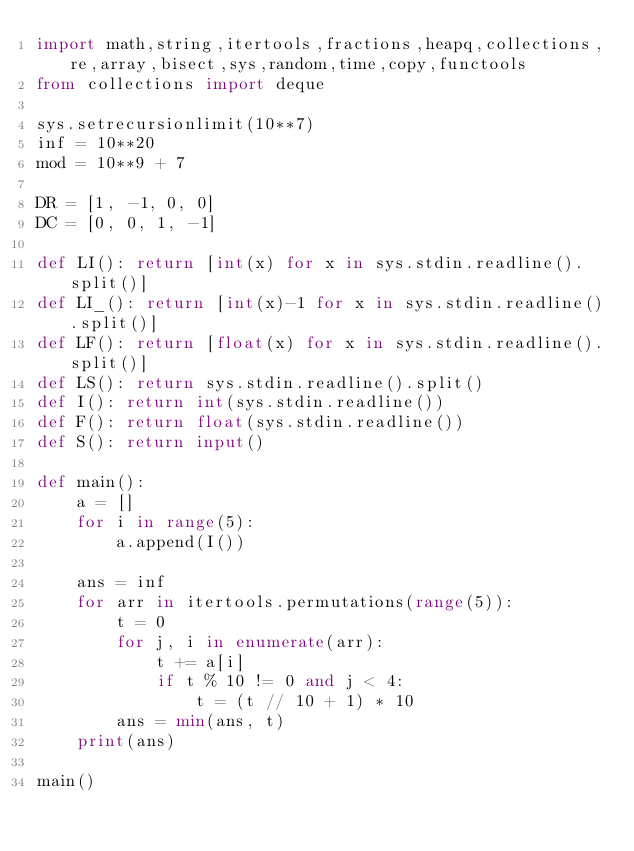<code> <loc_0><loc_0><loc_500><loc_500><_Python_>import math,string,itertools,fractions,heapq,collections,re,array,bisect,sys,random,time,copy,functools
from collections import deque

sys.setrecursionlimit(10**7)
inf = 10**20
mod = 10**9 + 7

DR = [1, -1, 0, 0]
DC = [0, 0, 1, -1]

def LI(): return [int(x) for x in sys.stdin.readline().split()]
def LI_(): return [int(x)-1 for x in sys.stdin.readline().split()]
def LF(): return [float(x) for x in sys.stdin.readline().split()]
def LS(): return sys.stdin.readline().split()
def I(): return int(sys.stdin.readline())
def F(): return float(sys.stdin.readline())
def S(): return input()
     
def main():
    a = []
    for i in range(5):
        a.append(I())

    ans = inf
    for arr in itertools.permutations(range(5)):
        t = 0
        for j, i in enumerate(arr):
            t += a[i]
            if t % 10 != 0 and j < 4:
                t = (t // 10 + 1) * 10
        ans = min(ans, t)
    print(ans)

main()

</code> 